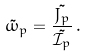Convert formula to latex. <formula><loc_0><loc_0><loc_500><loc_500>\tilde { \omega } _ { p } = \frac { \tilde { J _ { p } } } { \tilde { \mathcal { I } _ { p } } } \, .</formula> 